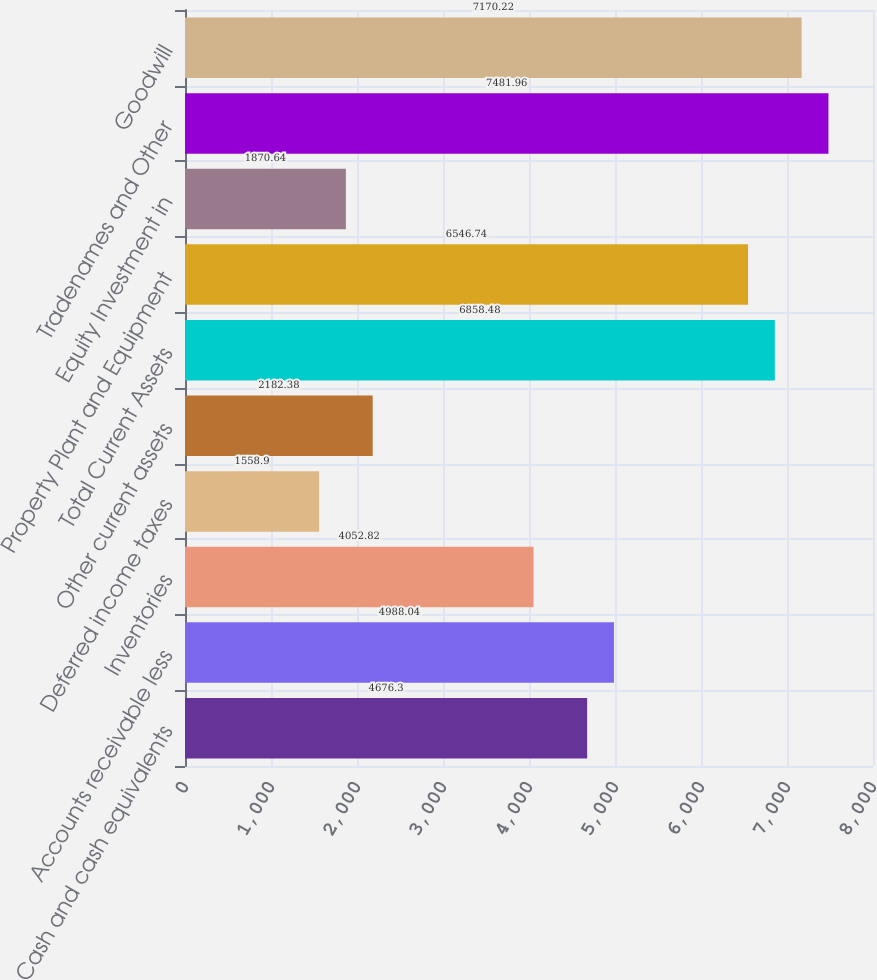Convert chart to OTSL. <chart><loc_0><loc_0><loc_500><loc_500><bar_chart><fcel>Cash and cash equivalents<fcel>Accounts receivable less<fcel>Inventories<fcel>Deferred income taxes<fcel>Other current assets<fcel>Total Current Assets<fcel>Property Plant and Equipment<fcel>Equity Investment in<fcel>Tradenames and Other<fcel>Goodwill<nl><fcel>4676.3<fcel>4988.04<fcel>4052.82<fcel>1558.9<fcel>2182.38<fcel>6858.48<fcel>6546.74<fcel>1870.64<fcel>7481.96<fcel>7170.22<nl></chart> 